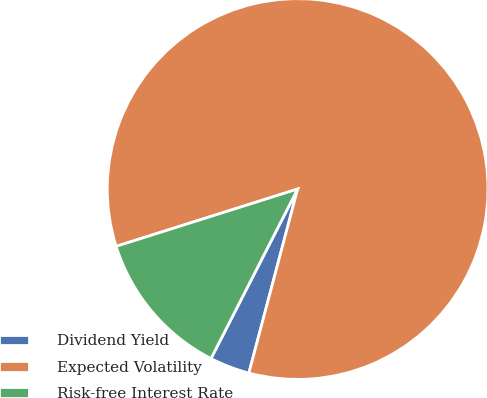Convert chart to OTSL. <chart><loc_0><loc_0><loc_500><loc_500><pie_chart><fcel>Dividend Yield<fcel>Expected Volatility<fcel>Risk-free Interest Rate<nl><fcel>3.4%<fcel>83.99%<fcel>12.61%<nl></chart> 